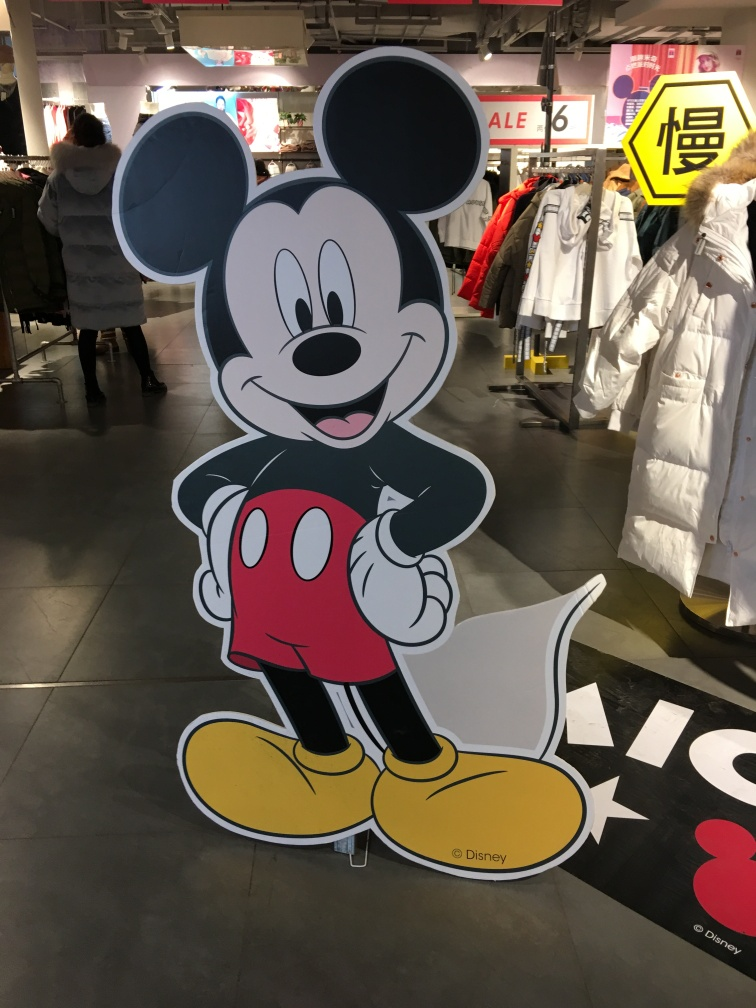Does the image include any branding or logos that indicate ownership or copyright? Yes, there is a logo visible at the bottom of the character signifying ownership and copyright by a well-known entertainment corporation, further indicating its commercial and promotional use. 